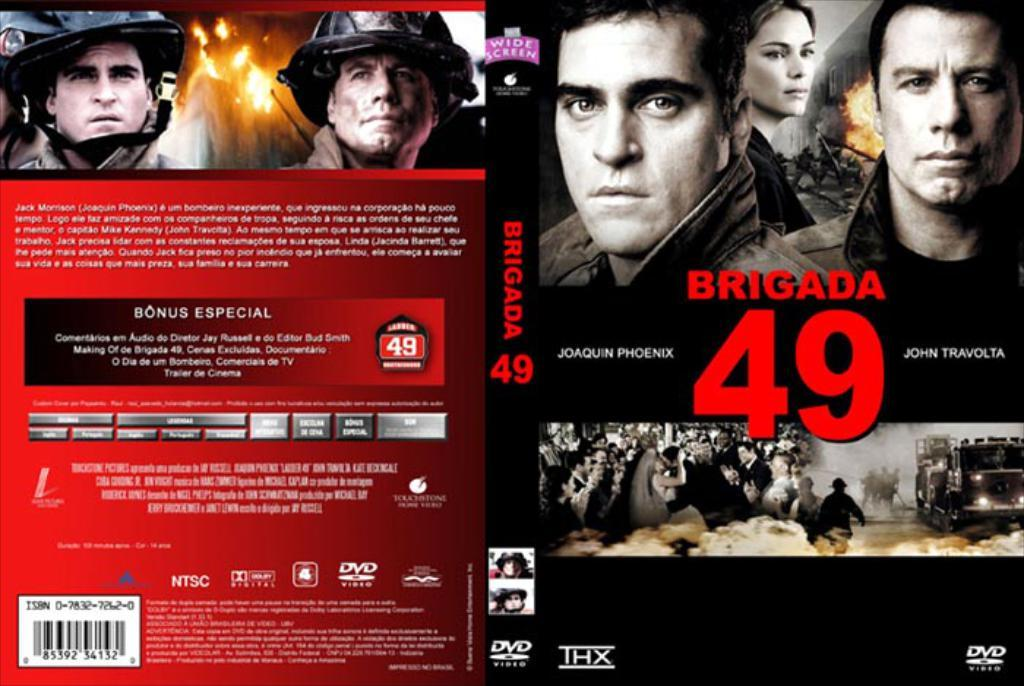What type of image is being described? The image is animated. What can be found in the center of the image? There is text in the center of the image. Where are the persons located in the image? There are persons on the top and right side of the image. What else is present on the right side of the image? There are vehicles on the right side of the image. Can you see a cracker in the image? There is no cracker present in the image. What type of nest can be found in the image? There is no nest present in the image. 